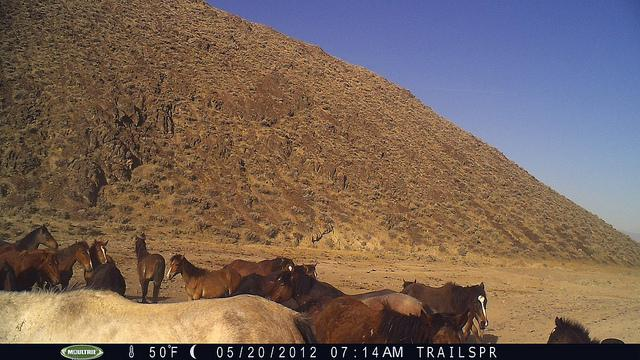What is the term used to call this group of horses? Please explain your reasoning. herd. Larger groups of horses are typically herded together. 